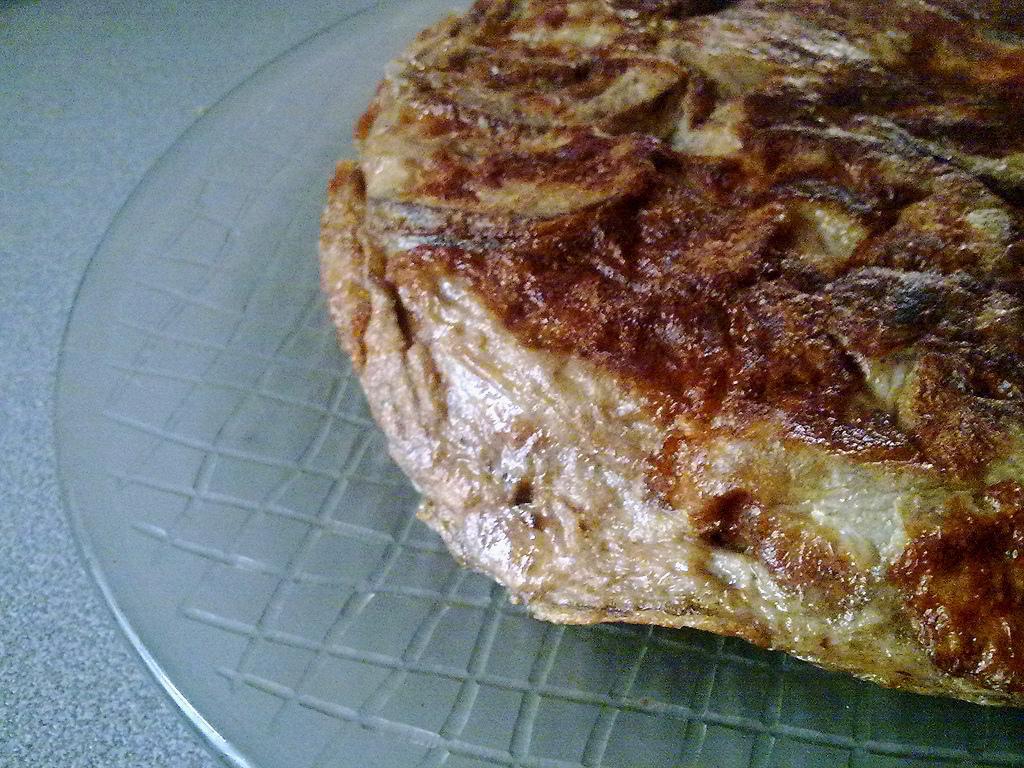Can you describe this image briefly? In this image I can see a food item which is placed on the glass. 